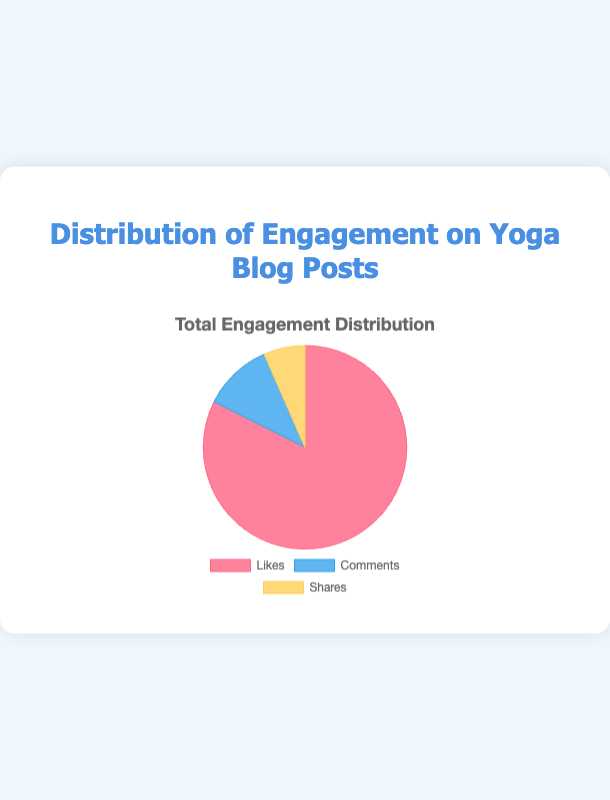Which type of engagement has the highest total number? To determine this, look at the pie chart and identify the largest segment. The segment representing 'Likes' is the largest, indicating that it has the highest total number.
Answer: Likes How many total engagements are there? Sum the total numbers of 'Likes', 'Comments', and 'Shares' from the pie chart: 8650 (Likes) + 1160 (Comments) + 690 (Shares) = 10500 total engagements.
Answer: 10500 What is the percentage of comments out of the total engagements? First, calculate the total engagements: 10500. Then, divide the total number of comments (1160) by the total engagements and multiply by 100: (1160 / 10500) * 100 ≈ 11.05%.
Answer: 11.05% What is the percentage difference between shares and comments? First, find the total numbers: Shares (690) and Comments (1160). Calculate the difference: 1160 - 690 = 470. Then divide by the total number of engagements and multiply by 100: (470 / 10500) * 100 ≈ 4.48%.
Answer: 4.48% Which engagement type contributes the least to the total? The smallest segment in the pie chart corresponds to 'Shares', indicating it has the lowest total number of engagements.
Answer: Shares What ratio do likes and shares have compared to comments? First, sum the total counts for likes and shares: 8650 (Likes) + 690 (Shares) = 9340. Then, divide this sum by the total comments: 9340 / 1160 ≈ 8.05.
Answer: 8.05 How many more likes are there compared to shares? Calculate the difference between total likes and total shares: 8650 (Likes) - 690 (Shares) = 7960.
Answer: 7960 If 'Shares' doubled, would it surpass 'Comments'? First, calculate the doubled 'Shares': 690 * 2 = 1380. Compare this with 'Comments' which is 1160. Since 1380 is greater than 1160, 'Shares' would surpass 'Comments'.
Answer: Yes What percentage of the total engagements are likes? Divide the total likes (8650) by the total engagements (10500) and multiply by 100: (8650 / 10500) * 100 ≈ 82.38%.
Answer: 82.38% How does the segment representing 'Likes' compare visually to 'Comments' and 'Shares'? The 'Likes' segment is significantly larger in size compared to both the 'Comments' and 'Shares' segments, indicating that likes have a substantially higher count.
Answer: Larger 